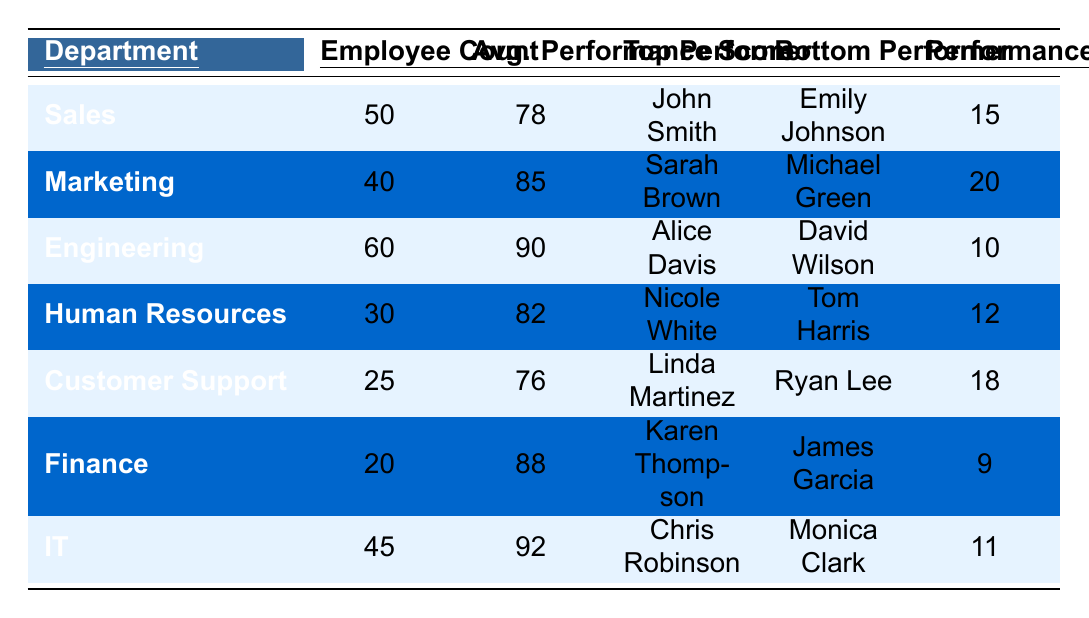What is the top performer in the Marketing department? According to the table, the Marketing department's top performer is Sarah Brown.
Answer: Sarah Brown How many employees are in the Engineering department? The table lists the Engineering department with an employee count of 60.
Answer: 60 What is the average performance score of the Sales department? The average performance score for the Sales department, as shown in the table, is 78.
Answer: 78 Which department has the highest average performance score? Comparing the average performance scores across departments, Engineering has the highest score at 90.
Answer: Engineering What is the performance improvement percentage for the IT department? The IT department's performance improvement percentage, as listed in the table, is 11%.
Answer: 11% Who is the bottom performer in Human Resources? The table specifies that the bottom performer in the Human Resources department is Tom Harris.
Answer: Tom Harris What is the total employee count across all departments? Summing the employee counts from the table gives: 50 (Sales) + 40 (Marketing) + 60 (Engineering) + 30 (HR) + 25 (Customer Support) + 20 (Finance) + 45 (IT) = 270.
Answer: 270 Is the average performance score for Customer Support higher than that of Sales? Customer Support has an average score of 76, while Sales has 78; therefore, Customer Support is not higher than Sales.
Answer: No What is the difference in average performance score between the Marketing and Finance departments? The average performance score for Marketing is 85 and for Finance is 88. To find the difference, subtract: 88 - 85 = 3.
Answer: 3 Which department shows the least performance improvement, and what is that percentage? By examining the performance improvement percentages, Finance at 9% shows the least improvement.
Answer: Finance, 9% 